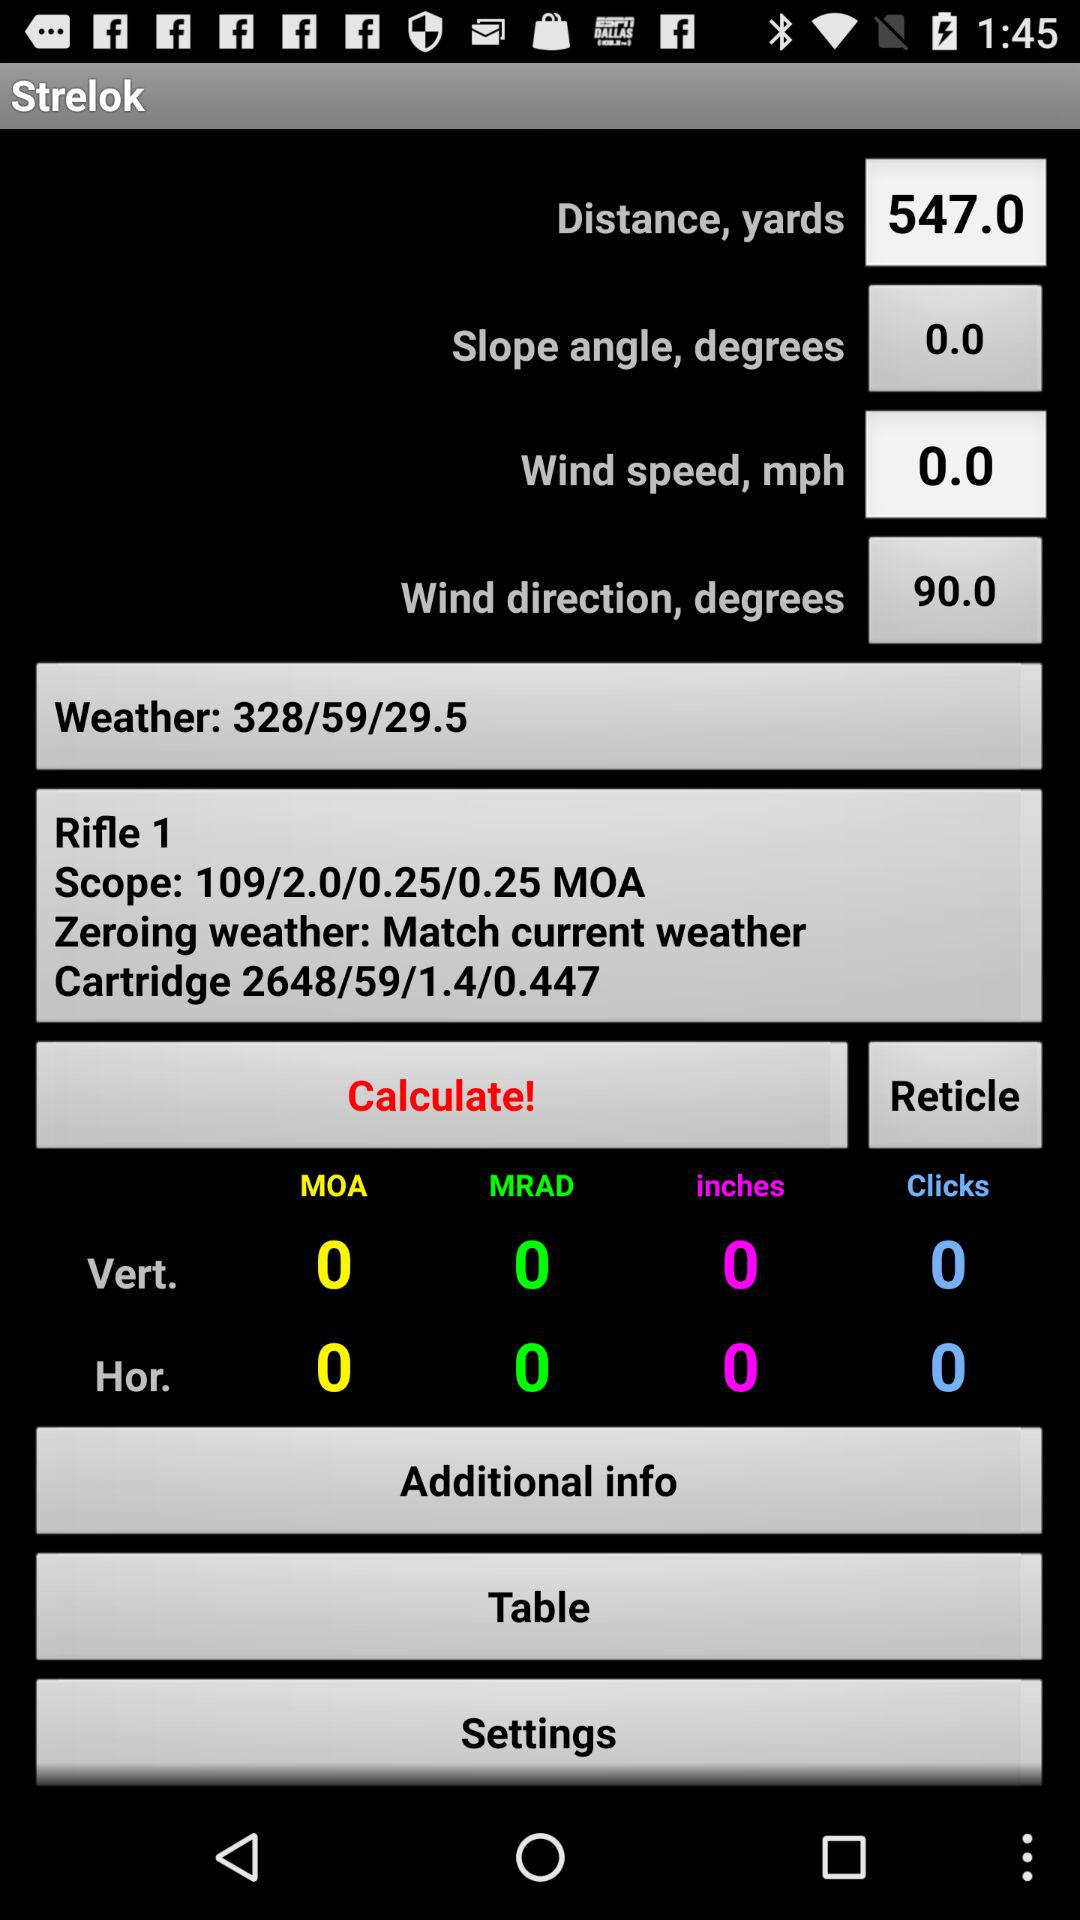What is the scope of Rifle 1? The scope of Rifle 1 is 109/2.0/0.25/0.25 MOA. 